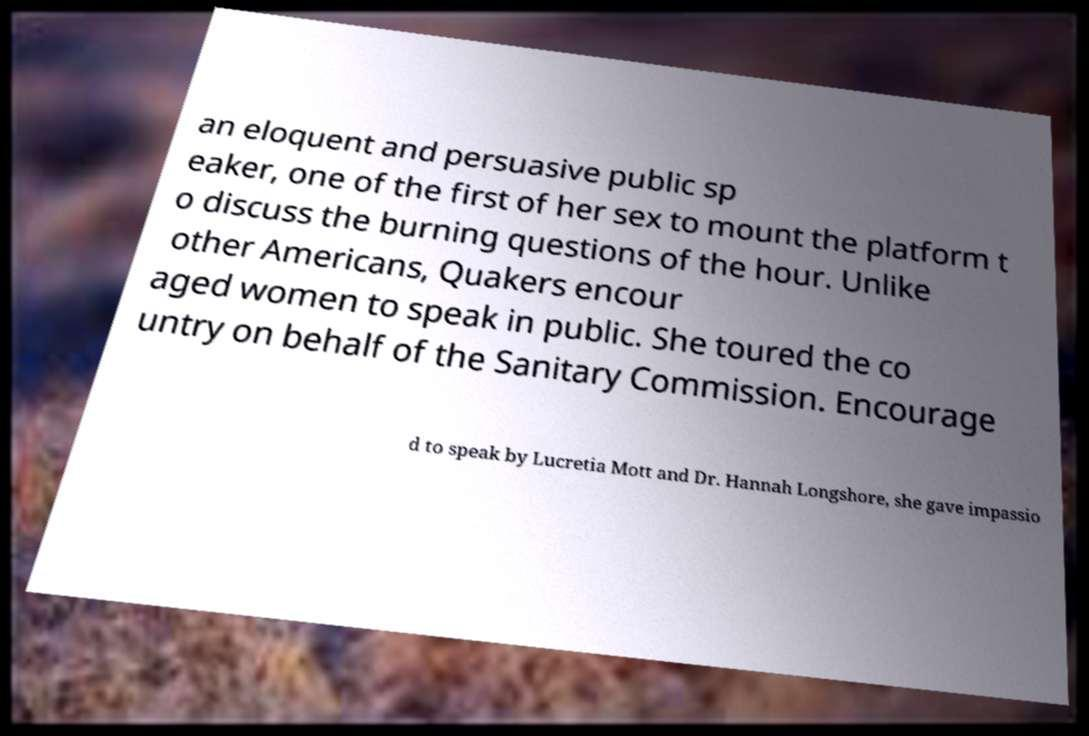What messages or text are displayed in this image? I need them in a readable, typed format. an eloquent and persuasive public sp eaker, one of the first of her sex to mount the platform t o discuss the burning questions of the hour. Unlike other Americans, Quakers encour aged women to speak in public. She toured the co untry on behalf of the Sanitary Commission. Encourage d to speak by Lucretia Mott and Dr. Hannah Longshore, she gave impassio 